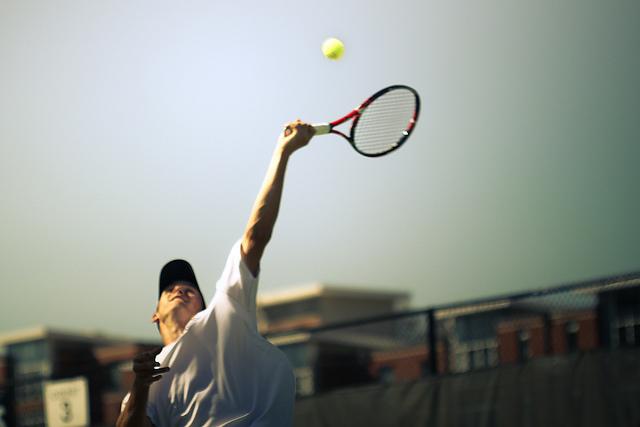Is this a dangerous sport?
Keep it brief. No. Is it a cloudy day?
Short answer required. No. What game is being played?
Concise answer only. Tennis. Is the tennis rack square?
Answer briefly. No. Will the guy catch the tennis ball?
Keep it brief. No. 